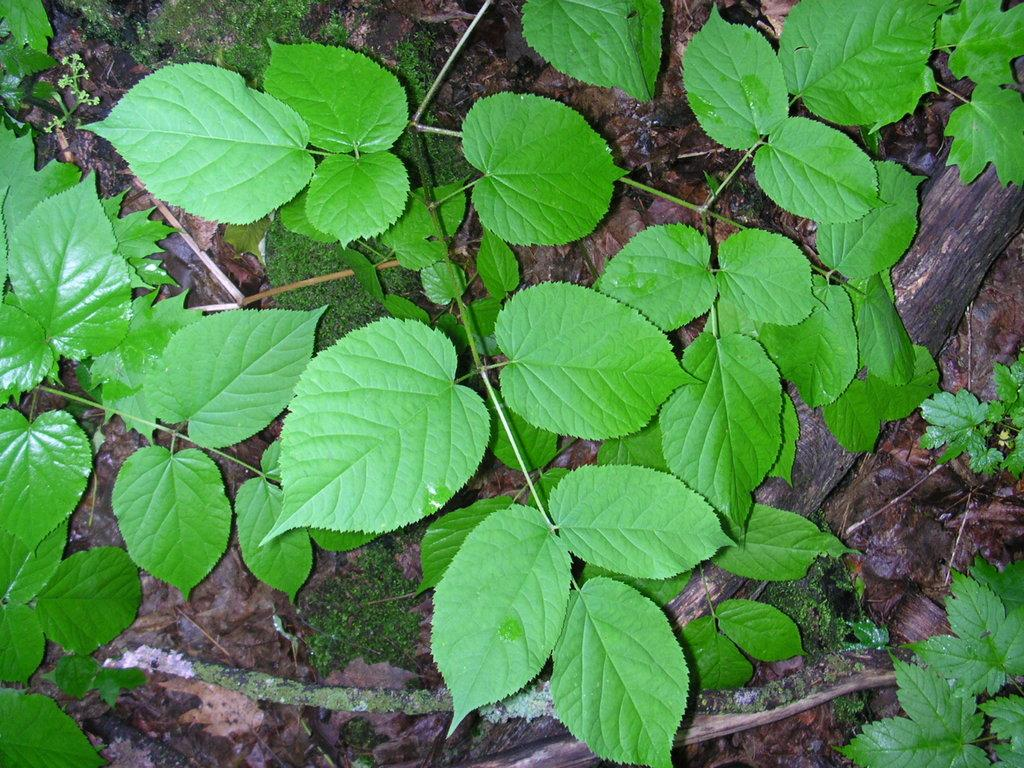What is located in the foreground of the image? There are plants and a wooden pole-like object on the ground in the foreground of the image. Can you describe the plants in the foreground? The provided facts do not give specific details about the plants, so we cannot describe them further. What is the wooden pole-like object used for? The purpose of the wooden pole-like object is not specified in the provided facts. What type of shirt is hanging on the wooden pole-like object in the image? There is no shirt present on the wooden pole-like object in the image. How many notebooks are lying on the ground near the plants in the image? There is no mention of notebooks in the provided facts, so we cannot determine if any are present in the image. 